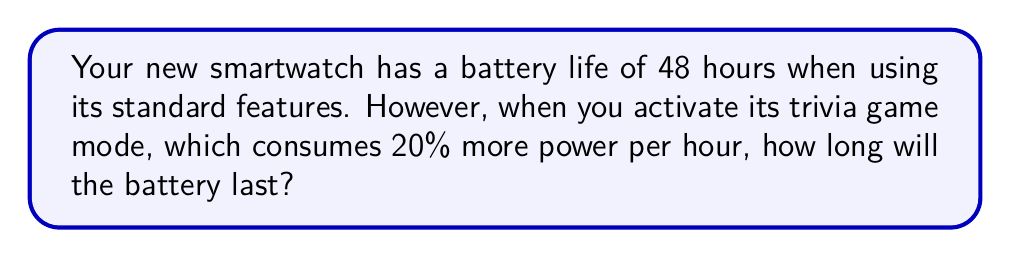What is the answer to this math problem? Let's approach this step-by-step:

1) First, we need to understand the relationship between power consumption and battery life. They are inversely proportional. If power consumption increases, battery life decreases.

2) Let's define some variables:
   $x$ = new battery life in hours
   $y$ = new power consumption rate

3) We know that the product of battery life and power consumption rate remains constant:
   $48 \cdot 1 = x \cdot y$

4) We're told that the trivia game mode consumes 20% more power. This means:
   $y = 1 + 20\% = 1 + 0.2 = 1.2$

5) Now we can set up our proportion:
   $48 \cdot 1 = x \cdot 1.2$

6) Solve for $x$:
   $x = \frac{48 \cdot 1}{1.2} = \frac{48}{1.2} = 40$

Therefore, the battery will last 40 hours when the trivia game mode is activated.
Answer: 40 hours 